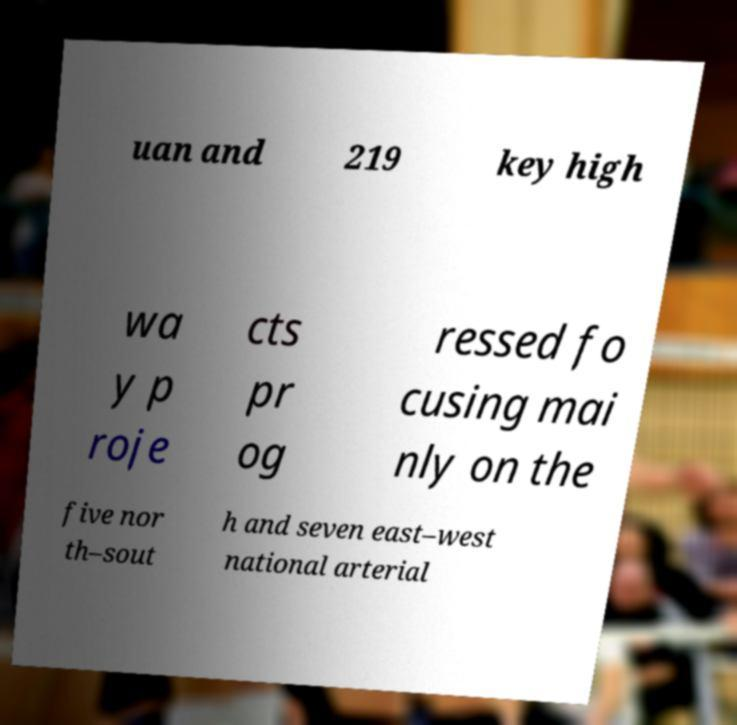What messages or text are displayed in this image? I need them in a readable, typed format. uan and 219 key high wa y p roje cts pr og ressed fo cusing mai nly on the five nor th–sout h and seven east–west national arterial 